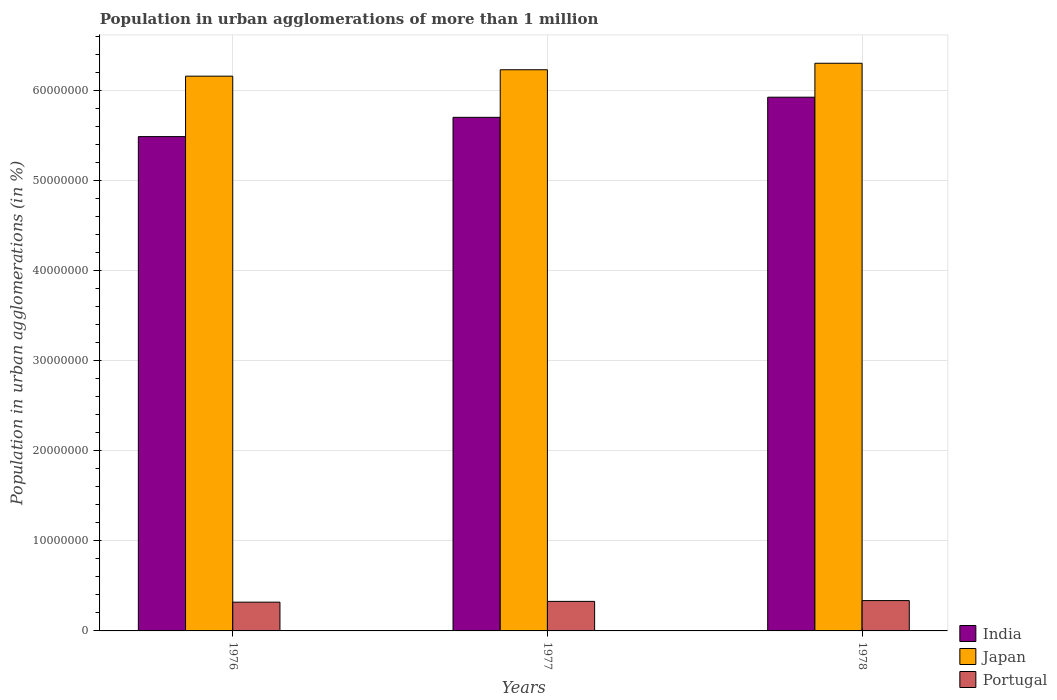How many different coloured bars are there?
Your answer should be very brief. 3. How many groups of bars are there?
Your response must be concise. 3. Are the number of bars per tick equal to the number of legend labels?
Your answer should be compact. Yes. How many bars are there on the 3rd tick from the left?
Offer a very short reply. 3. In how many cases, is the number of bars for a given year not equal to the number of legend labels?
Your answer should be very brief. 0. What is the population in urban agglomerations in India in 1977?
Offer a terse response. 5.70e+07. Across all years, what is the maximum population in urban agglomerations in Japan?
Provide a short and direct response. 6.31e+07. Across all years, what is the minimum population in urban agglomerations in Japan?
Make the answer very short. 6.16e+07. In which year was the population in urban agglomerations in Portugal maximum?
Keep it short and to the point. 1978. In which year was the population in urban agglomerations in Portugal minimum?
Offer a terse response. 1976. What is the total population in urban agglomerations in India in the graph?
Your answer should be very brief. 1.71e+08. What is the difference between the population in urban agglomerations in Portugal in 1976 and that in 1977?
Provide a short and direct response. -8.56e+04. What is the difference between the population in urban agglomerations in Japan in 1977 and the population in urban agglomerations in Portugal in 1978?
Provide a succinct answer. 5.90e+07. What is the average population in urban agglomerations in Japan per year?
Offer a very short reply. 6.23e+07. In the year 1977, what is the difference between the population in urban agglomerations in India and population in urban agglomerations in Portugal?
Make the answer very short. 5.38e+07. What is the ratio of the population in urban agglomerations in Portugal in 1976 to that in 1978?
Keep it short and to the point. 0.95. What is the difference between the highest and the second highest population in urban agglomerations in Portugal?
Offer a terse response. 8.82e+04. What is the difference between the highest and the lowest population in urban agglomerations in Japan?
Provide a short and direct response. 1.43e+06. In how many years, is the population in urban agglomerations in Portugal greater than the average population in urban agglomerations in Portugal taken over all years?
Make the answer very short. 1. What does the 2nd bar from the right in 1976 represents?
Your response must be concise. Japan. Is it the case that in every year, the sum of the population in urban agglomerations in Portugal and population in urban agglomerations in Japan is greater than the population in urban agglomerations in India?
Your answer should be compact. Yes. Are the values on the major ticks of Y-axis written in scientific E-notation?
Offer a terse response. No. Does the graph contain any zero values?
Make the answer very short. No. Does the graph contain grids?
Provide a succinct answer. Yes. Where does the legend appear in the graph?
Provide a short and direct response. Bottom right. How are the legend labels stacked?
Make the answer very short. Vertical. What is the title of the graph?
Your answer should be compact. Population in urban agglomerations of more than 1 million. Does "Greece" appear as one of the legend labels in the graph?
Provide a short and direct response. No. What is the label or title of the X-axis?
Provide a short and direct response. Years. What is the label or title of the Y-axis?
Offer a terse response. Population in urban agglomerations (in %). What is the Population in urban agglomerations (in %) of India in 1976?
Offer a very short reply. 5.49e+07. What is the Population in urban agglomerations (in %) in Japan in 1976?
Ensure brevity in your answer.  6.16e+07. What is the Population in urban agglomerations (in %) in Portugal in 1976?
Provide a short and direct response. 3.19e+06. What is the Population in urban agglomerations (in %) in India in 1977?
Keep it short and to the point. 5.70e+07. What is the Population in urban agglomerations (in %) in Japan in 1977?
Make the answer very short. 6.23e+07. What is the Population in urban agglomerations (in %) in Portugal in 1977?
Offer a terse response. 3.28e+06. What is the Population in urban agglomerations (in %) of India in 1978?
Provide a succinct answer. 5.93e+07. What is the Population in urban agglomerations (in %) in Japan in 1978?
Ensure brevity in your answer.  6.31e+07. What is the Population in urban agglomerations (in %) of Portugal in 1978?
Keep it short and to the point. 3.37e+06. Across all years, what is the maximum Population in urban agglomerations (in %) in India?
Offer a very short reply. 5.93e+07. Across all years, what is the maximum Population in urban agglomerations (in %) of Japan?
Offer a terse response. 6.31e+07. Across all years, what is the maximum Population in urban agglomerations (in %) of Portugal?
Provide a short and direct response. 3.37e+06. Across all years, what is the minimum Population in urban agglomerations (in %) in India?
Offer a very short reply. 5.49e+07. Across all years, what is the minimum Population in urban agglomerations (in %) of Japan?
Offer a very short reply. 6.16e+07. Across all years, what is the minimum Population in urban agglomerations (in %) of Portugal?
Give a very brief answer. 3.19e+06. What is the total Population in urban agglomerations (in %) in India in the graph?
Make the answer very short. 1.71e+08. What is the total Population in urban agglomerations (in %) in Japan in the graph?
Provide a succinct answer. 1.87e+08. What is the total Population in urban agglomerations (in %) of Portugal in the graph?
Provide a short and direct response. 9.84e+06. What is the difference between the Population in urban agglomerations (in %) of India in 1976 and that in 1977?
Your response must be concise. -2.14e+06. What is the difference between the Population in urban agglomerations (in %) in Japan in 1976 and that in 1977?
Provide a short and direct response. -7.11e+05. What is the difference between the Population in urban agglomerations (in %) in Portugal in 1976 and that in 1977?
Make the answer very short. -8.56e+04. What is the difference between the Population in urban agglomerations (in %) in India in 1976 and that in 1978?
Provide a short and direct response. -4.38e+06. What is the difference between the Population in urban agglomerations (in %) of Japan in 1976 and that in 1978?
Keep it short and to the point. -1.43e+06. What is the difference between the Population in urban agglomerations (in %) in Portugal in 1976 and that in 1978?
Offer a very short reply. -1.74e+05. What is the difference between the Population in urban agglomerations (in %) of India in 1977 and that in 1978?
Ensure brevity in your answer.  -2.24e+06. What is the difference between the Population in urban agglomerations (in %) of Japan in 1977 and that in 1978?
Your response must be concise. -7.22e+05. What is the difference between the Population in urban agglomerations (in %) in Portugal in 1977 and that in 1978?
Ensure brevity in your answer.  -8.82e+04. What is the difference between the Population in urban agglomerations (in %) in India in 1976 and the Population in urban agglomerations (in %) in Japan in 1977?
Provide a succinct answer. -7.43e+06. What is the difference between the Population in urban agglomerations (in %) in India in 1976 and the Population in urban agglomerations (in %) in Portugal in 1977?
Provide a short and direct response. 5.16e+07. What is the difference between the Population in urban agglomerations (in %) in Japan in 1976 and the Population in urban agglomerations (in %) in Portugal in 1977?
Give a very brief answer. 5.83e+07. What is the difference between the Population in urban agglomerations (in %) of India in 1976 and the Population in urban agglomerations (in %) of Japan in 1978?
Provide a succinct answer. -8.15e+06. What is the difference between the Population in urban agglomerations (in %) of India in 1976 and the Population in urban agglomerations (in %) of Portugal in 1978?
Offer a terse response. 5.15e+07. What is the difference between the Population in urban agglomerations (in %) in Japan in 1976 and the Population in urban agglomerations (in %) in Portugal in 1978?
Your response must be concise. 5.83e+07. What is the difference between the Population in urban agglomerations (in %) of India in 1977 and the Population in urban agglomerations (in %) of Japan in 1978?
Provide a succinct answer. -6.01e+06. What is the difference between the Population in urban agglomerations (in %) in India in 1977 and the Population in urban agglomerations (in %) in Portugal in 1978?
Make the answer very short. 5.37e+07. What is the difference between the Population in urban agglomerations (in %) in Japan in 1977 and the Population in urban agglomerations (in %) in Portugal in 1978?
Provide a succinct answer. 5.90e+07. What is the average Population in urban agglomerations (in %) of India per year?
Offer a very short reply. 5.71e+07. What is the average Population in urban agglomerations (in %) of Japan per year?
Your answer should be very brief. 6.23e+07. What is the average Population in urban agglomerations (in %) of Portugal per year?
Provide a short and direct response. 3.28e+06. In the year 1976, what is the difference between the Population in urban agglomerations (in %) in India and Population in urban agglomerations (in %) in Japan?
Offer a terse response. -6.71e+06. In the year 1976, what is the difference between the Population in urban agglomerations (in %) in India and Population in urban agglomerations (in %) in Portugal?
Make the answer very short. 5.17e+07. In the year 1976, what is the difference between the Population in urban agglomerations (in %) of Japan and Population in urban agglomerations (in %) of Portugal?
Keep it short and to the point. 5.84e+07. In the year 1977, what is the difference between the Population in urban agglomerations (in %) of India and Population in urban agglomerations (in %) of Japan?
Your answer should be compact. -5.28e+06. In the year 1977, what is the difference between the Population in urban agglomerations (in %) in India and Population in urban agglomerations (in %) in Portugal?
Offer a very short reply. 5.38e+07. In the year 1977, what is the difference between the Population in urban agglomerations (in %) in Japan and Population in urban agglomerations (in %) in Portugal?
Offer a terse response. 5.91e+07. In the year 1978, what is the difference between the Population in urban agglomerations (in %) of India and Population in urban agglomerations (in %) of Japan?
Keep it short and to the point. -3.77e+06. In the year 1978, what is the difference between the Population in urban agglomerations (in %) of India and Population in urban agglomerations (in %) of Portugal?
Give a very brief answer. 5.59e+07. In the year 1978, what is the difference between the Population in urban agglomerations (in %) in Japan and Population in urban agglomerations (in %) in Portugal?
Offer a terse response. 5.97e+07. What is the ratio of the Population in urban agglomerations (in %) in India in 1976 to that in 1977?
Offer a terse response. 0.96. What is the ratio of the Population in urban agglomerations (in %) in Japan in 1976 to that in 1977?
Give a very brief answer. 0.99. What is the ratio of the Population in urban agglomerations (in %) in Portugal in 1976 to that in 1977?
Your answer should be compact. 0.97. What is the ratio of the Population in urban agglomerations (in %) in India in 1976 to that in 1978?
Provide a succinct answer. 0.93. What is the ratio of the Population in urban agglomerations (in %) in Japan in 1976 to that in 1978?
Keep it short and to the point. 0.98. What is the ratio of the Population in urban agglomerations (in %) of Portugal in 1976 to that in 1978?
Ensure brevity in your answer.  0.95. What is the ratio of the Population in urban agglomerations (in %) of India in 1977 to that in 1978?
Keep it short and to the point. 0.96. What is the ratio of the Population in urban agglomerations (in %) of Portugal in 1977 to that in 1978?
Keep it short and to the point. 0.97. What is the difference between the highest and the second highest Population in urban agglomerations (in %) in India?
Offer a terse response. 2.24e+06. What is the difference between the highest and the second highest Population in urban agglomerations (in %) in Japan?
Give a very brief answer. 7.22e+05. What is the difference between the highest and the second highest Population in urban agglomerations (in %) of Portugal?
Provide a short and direct response. 8.82e+04. What is the difference between the highest and the lowest Population in urban agglomerations (in %) of India?
Offer a very short reply. 4.38e+06. What is the difference between the highest and the lowest Population in urban agglomerations (in %) of Japan?
Ensure brevity in your answer.  1.43e+06. What is the difference between the highest and the lowest Population in urban agglomerations (in %) in Portugal?
Provide a short and direct response. 1.74e+05. 